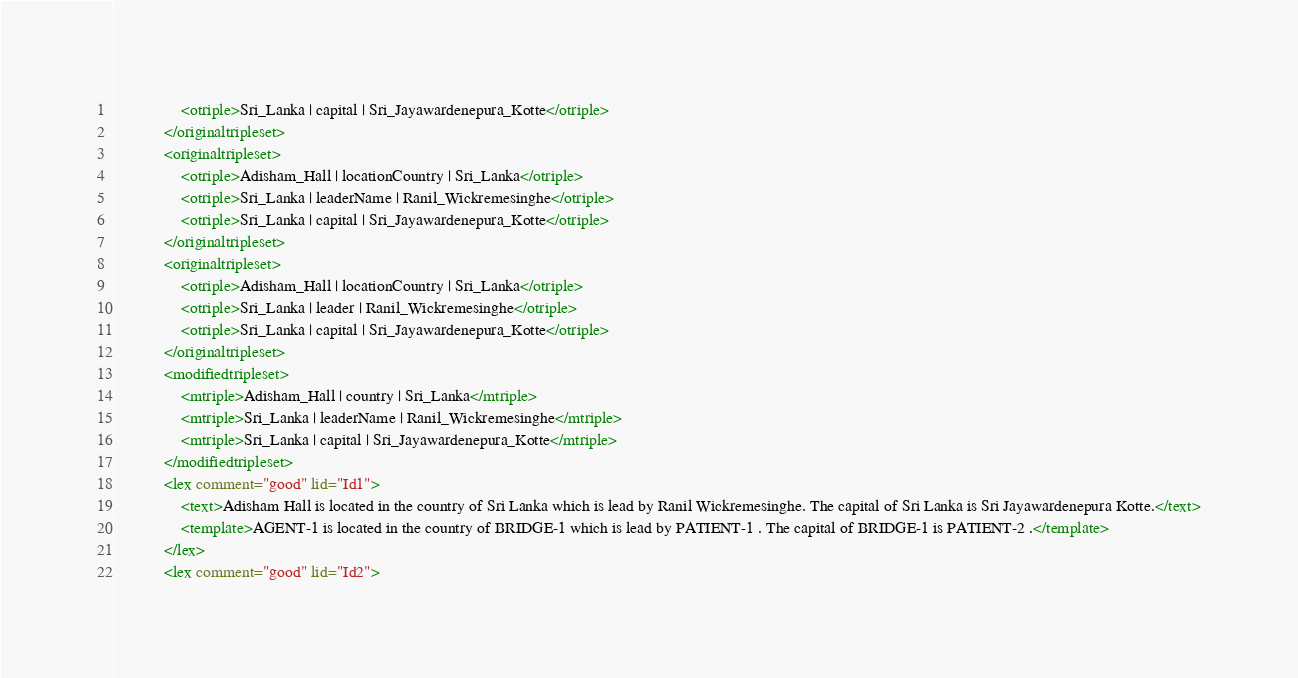Convert code to text. <code><loc_0><loc_0><loc_500><loc_500><_XML_>				<otriple>Sri_Lanka | capital | Sri_Jayawardenepura_Kotte</otriple>
			</originaltripleset>
			<originaltripleset>
				<otriple>Adisham_Hall | locationCountry | Sri_Lanka</otriple>
				<otriple>Sri_Lanka | leaderName | Ranil_Wickremesinghe</otriple>
				<otriple>Sri_Lanka | capital | Sri_Jayawardenepura_Kotte</otriple>
			</originaltripleset>
			<originaltripleset>
				<otriple>Adisham_Hall | locationCountry | Sri_Lanka</otriple>
				<otriple>Sri_Lanka | leader | Ranil_Wickremesinghe</otriple>
				<otriple>Sri_Lanka | capital | Sri_Jayawardenepura_Kotte</otriple>
			</originaltripleset>
			<modifiedtripleset>
				<mtriple>Adisham_Hall | country | Sri_Lanka</mtriple>
				<mtriple>Sri_Lanka | leaderName | Ranil_Wickremesinghe</mtriple>
				<mtriple>Sri_Lanka | capital | Sri_Jayawardenepura_Kotte</mtriple>
			</modifiedtripleset>
			<lex comment="good" lid="Id1">
				<text>Adisham Hall is located in the country of Sri Lanka which is lead by Ranil Wickremesinghe. The capital of Sri Lanka is Sri Jayawardenepura Kotte.</text>
				<template>AGENT-1 is located in the country of BRIDGE-1 which is lead by PATIENT-1 . The capital of BRIDGE-1 is PATIENT-2 .</template>
			</lex>
			<lex comment="good" lid="Id2"></code> 